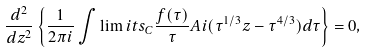Convert formula to latex. <formula><loc_0><loc_0><loc_500><loc_500>\frac { d ^ { 2 } } { d z ^ { 2 } } \left \{ \frac { 1 } { 2 \pi i } \int \lim i t s _ { C } \frac { f ( \tau ) } { \tau } A i ( \tau ^ { 1 / 3 } z - \tau ^ { 4 / 3 } ) d \tau \right \} = 0 ,</formula> 